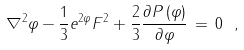Convert formula to latex. <formula><loc_0><loc_0><loc_500><loc_500>\nabla ^ { 2 } \varphi - \frac { 1 } { 3 } e ^ { 2 \varphi } F ^ { 2 } + \frac { 2 } { 3 } \frac { \partial P \left ( \varphi \right ) } { \partial \varphi } \, = \, 0 \ ,</formula> 